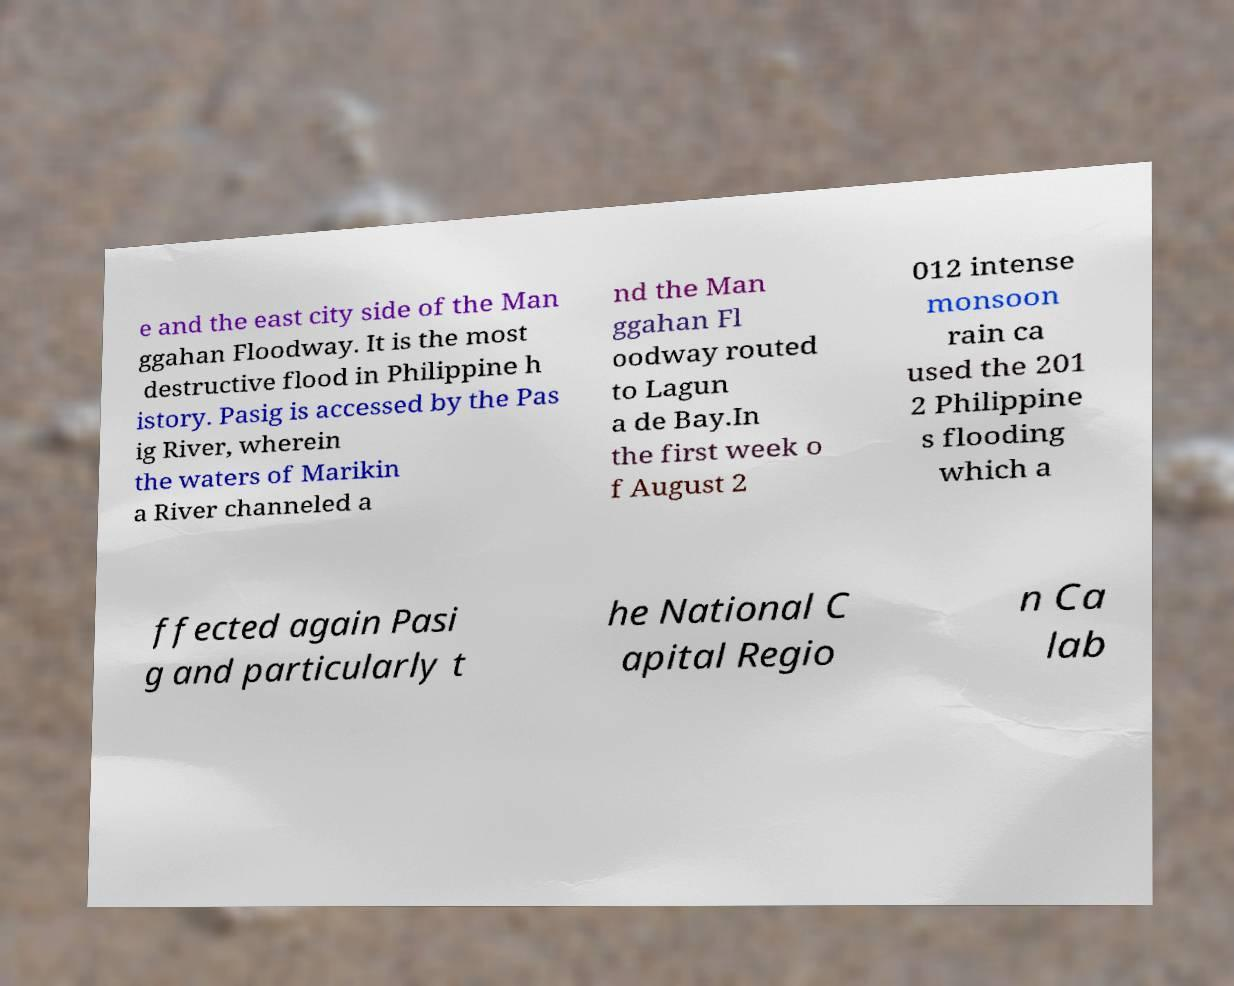I need the written content from this picture converted into text. Can you do that? e and the east city side of the Man ggahan Floodway. It is the most destructive flood in Philippine h istory. Pasig is accessed by the Pas ig River, wherein the waters of Marikin a River channeled a nd the Man ggahan Fl oodway routed to Lagun a de Bay.In the first week o f August 2 012 intense monsoon rain ca used the 201 2 Philippine s flooding which a ffected again Pasi g and particularly t he National C apital Regio n Ca lab 